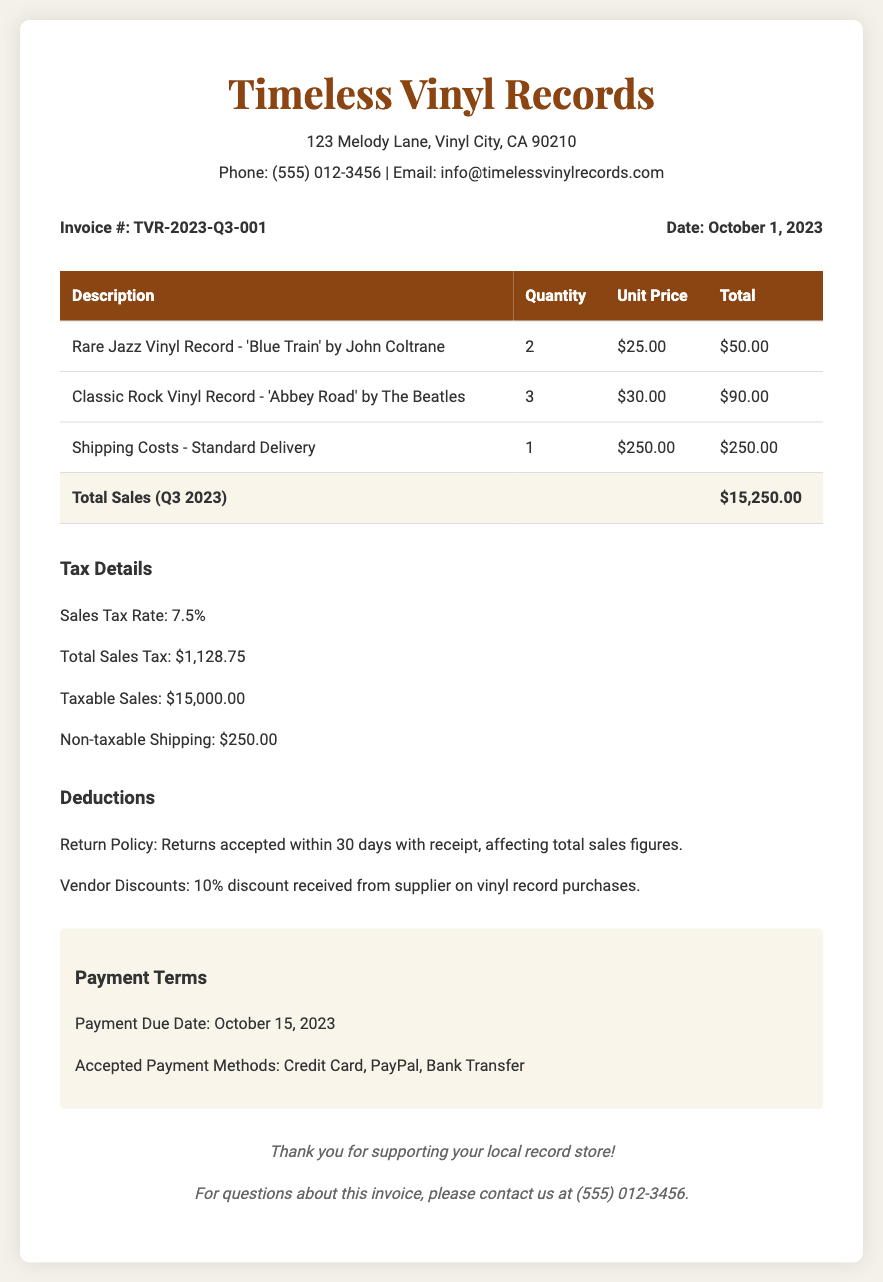what is the invoice number? The invoice number is listed at the top of the document under invoice details.
Answer: TVR-2023-Q3-001 what is the total sales amount? The total sales amount is stated in the table under "Total Sales (Q3 2023)."
Answer: $15,250.00 what is the sales tax rate? The sales tax rate is mentioned in the tax details section of the document.
Answer: 7.5% how much is the total sales tax? The total sales tax can be found in the tax details section, detailing the tax amount applied.
Answer: $1,128.75 what item is shipped for $250.00? The document specifies the description for the item with that cost under "Shipping Costs."
Answer: Shipping Costs - Standard Delivery what is the payment due date? The payment due date is explicitly stated in the payment terms section of the document.
Answer: October 15, 2023 how many Classic Rock Vinyl Records were sold? The quantity of the Classic Rock Vinyl Records sold is provided in the table of items listed.
Answer: 3 what is the non-taxable shipping amount? The non-taxable shipping amount is outlined in the tax details, indicating the specific shipping costs not subject to tax.
Answer: $250.00 what discount did you receive from the supplier? The deductions section mentions the percentage discount regarding vinyl record purchases from the supplier.
Answer: 10% 